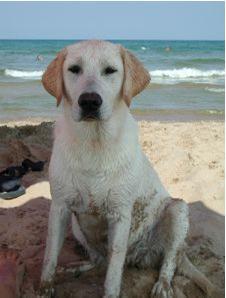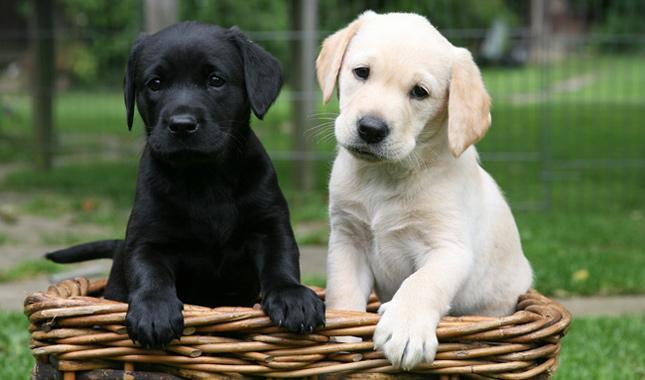The first image is the image on the left, the second image is the image on the right. Assess this claim about the two images: "There is exactly one adult dog lying in the grass.". Correct or not? Answer yes or no. No. The first image is the image on the left, the second image is the image on the right. Examine the images to the left and right. Is the description "There is exactly one sitting dog in one of the images." accurate? Answer yes or no. Yes. 